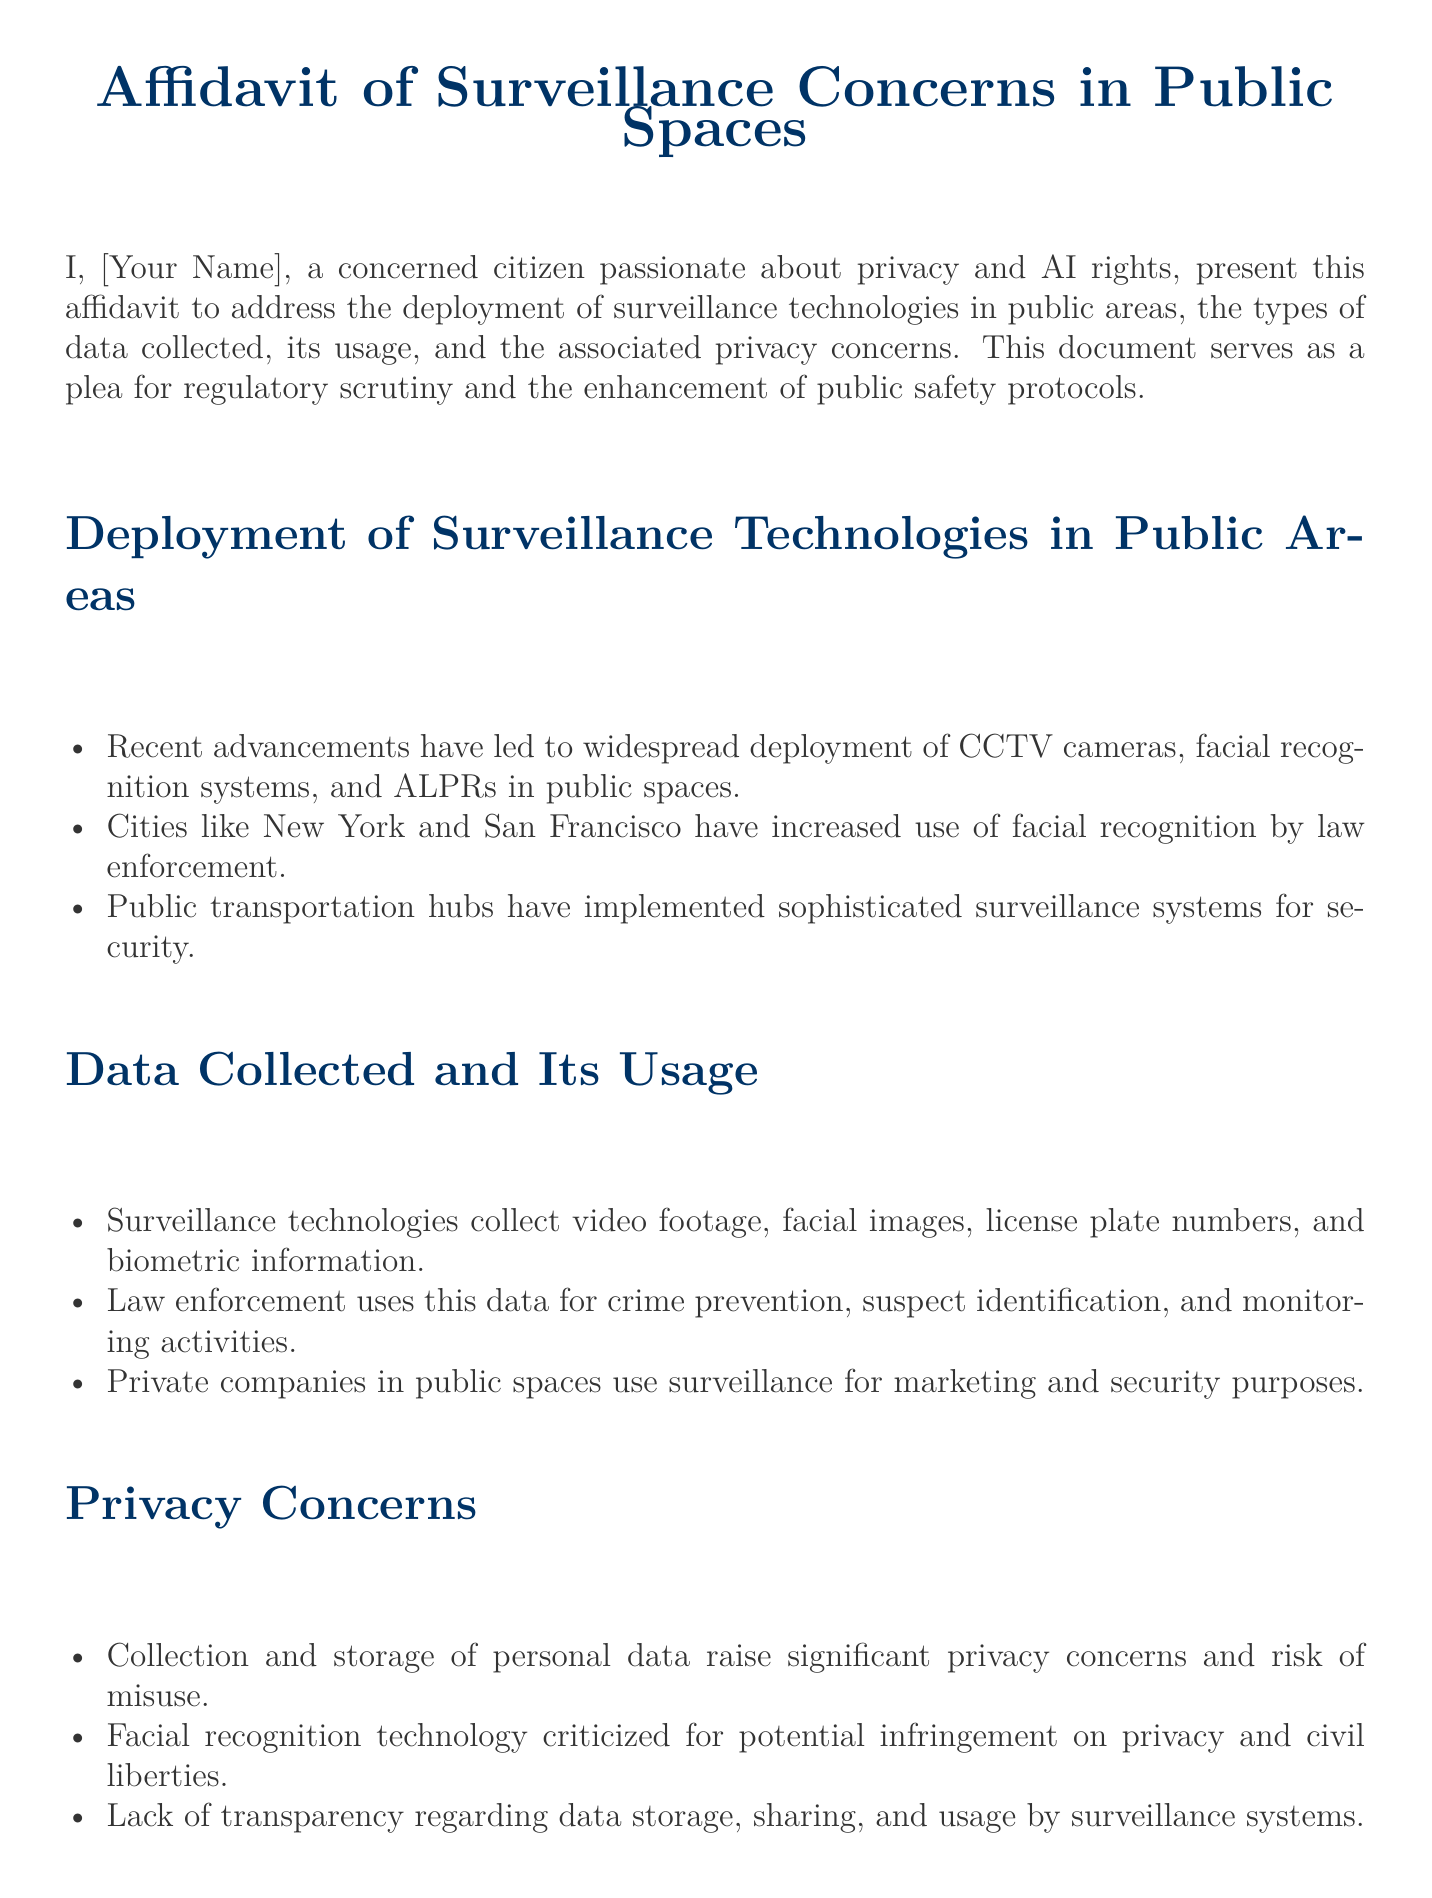What surveillance technologies are mentioned? The document lists CCTV cameras, facial recognition systems, and ALPRs as surveillance technologies deployed in public areas.
Answer: CCTV cameras, facial recognition systems, ALPRs Which cities are noted for increased use of facial recognition? The affidavit specifies New York and San Francisco as cities where facial recognition use has increased by law enforcement.
Answer: New York, San Francisco What types of data are collected through surveillance technologies? The document states that video footage, facial images, and license plate numbers are examples of data collected by surveillance technologies.
Answer: Video footage, facial images, license plate numbers What is a major privacy concern outlined in the affidavit? The affidavit points out the significant privacy concern is the collection and storage of personal data, which raises risks of misuse.
Answer: Misuse of personal data What regulatory action is being urged? The document calls for the introduction of stringent regulations governing surveillance technologies in public spaces.
Answer: Stringent regulations How does the document describe the storage practices of collected data? It mentions there is a lack of transparency regarding data storage, sharing, and usage by surveillance systems.
Answer: Lack of transparency What is the purpose of private companies using surveillance data? The affidavit specifies that private companies use surveillance for marketing and security purposes.
Answer: Marketing, security What plea does the affidavit make regarding public safety protocols? The document requests the enhancement of public safety protocols to balance security needs with privacy protection.
Answer: Enhance public safety protocols 